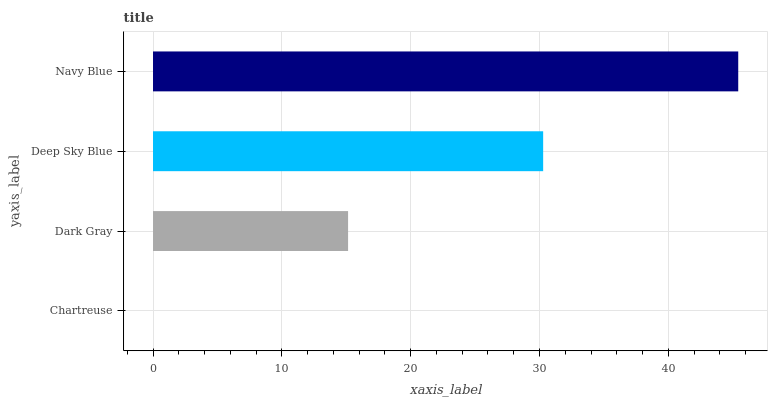Is Chartreuse the minimum?
Answer yes or no. Yes. Is Navy Blue the maximum?
Answer yes or no. Yes. Is Dark Gray the minimum?
Answer yes or no. No. Is Dark Gray the maximum?
Answer yes or no. No. Is Dark Gray greater than Chartreuse?
Answer yes or no. Yes. Is Chartreuse less than Dark Gray?
Answer yes or no. Yes. Is Chartreuse greater than Dark Gray?
Answer yes or no. No. Is Dark Gray less than Chartreuse?
Answer yes or no. No. Is Deep Sky Blue the high median?
Answer yes or no. Yes. Is Dark Gray the low median?
Answer yes or no. Yes. Is Chartreuse the high median?
Answer yes or no. No. Is Chartreuse the low median?
Answer yes or no. No. 